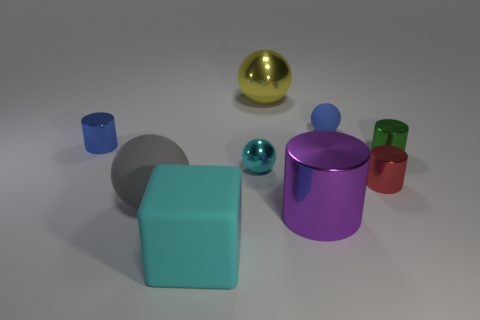How many tiny blue metal objects are to the left of the tiny sphere behind the green cylinder?
Provide a succinct answer. 1. Is there a gray object of the same shape as the yellow thing?
Offer a very short reply. Yes. Does the metal sphere behind the blue cylinder have the same size as the shiny sphere that is in front of the small matte object?
Offer a terse response. No. What is the shape of the cyan thing that is behind the small metallic cylinder in front of the cyan metallic ball?
Your answer should be compact. Sphere. What number of blue metallic things have the same size as the cyan metallic sphere?
Keep it short and to the point. 1. Are any big matte cylinders visible?
Offer a very short reply. No. Is there any other thing that has the same color as the large block?
Your answer should be very brief. Yes. There is a tiny cyan thing that is made of the same material as the green cylinder; what is its shape?
Your answer should be very brief. Sphere. What color is the big object that is behind the tiny rubber thing that is left of the thing on the right side of the tiny red metal thing?
Your answer should be compact. Yellow. Are there the same number of tiny blue balls on the right side of the big block and cubes?
Provide a short and direct response. Yes. 